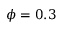Convert formula to latex. <formula><loc_0><loc_0><loc_500><loc_500>\phi = 0 . 3</formula> 